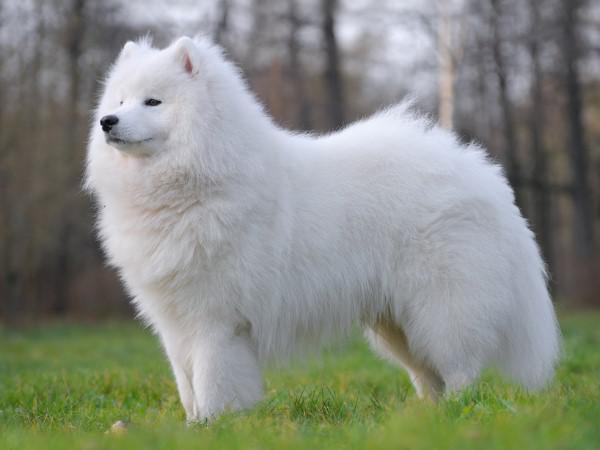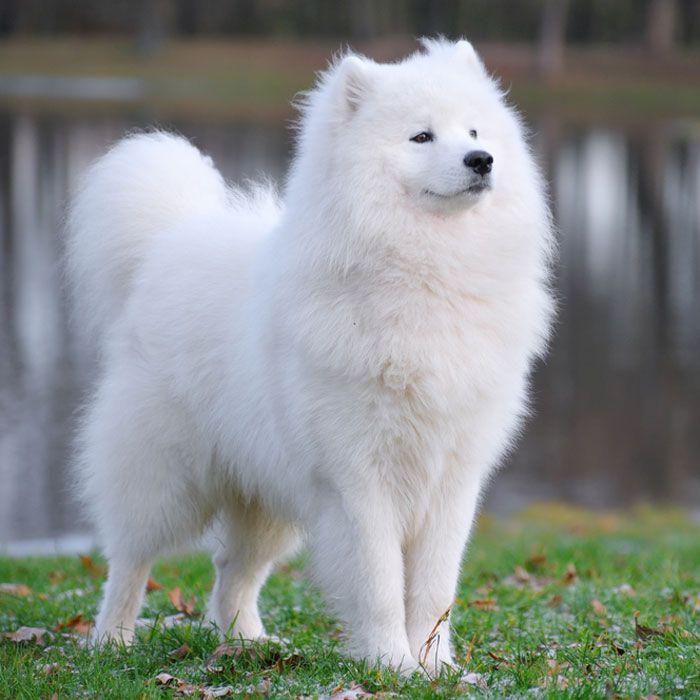The first image is the image on the left, the second image is the image on the right. Evaluate the accuracy of this statement regarding the images: "The dog in the left photo has its tongue out.". Is it true? Answer yes or no. No. The first image is the image on the left, the second image is the image on the right. Considering the images on both sides, is "At least one image shows a white dog standing on all fours in the grass." valid? Answer yes or no. Yes. 